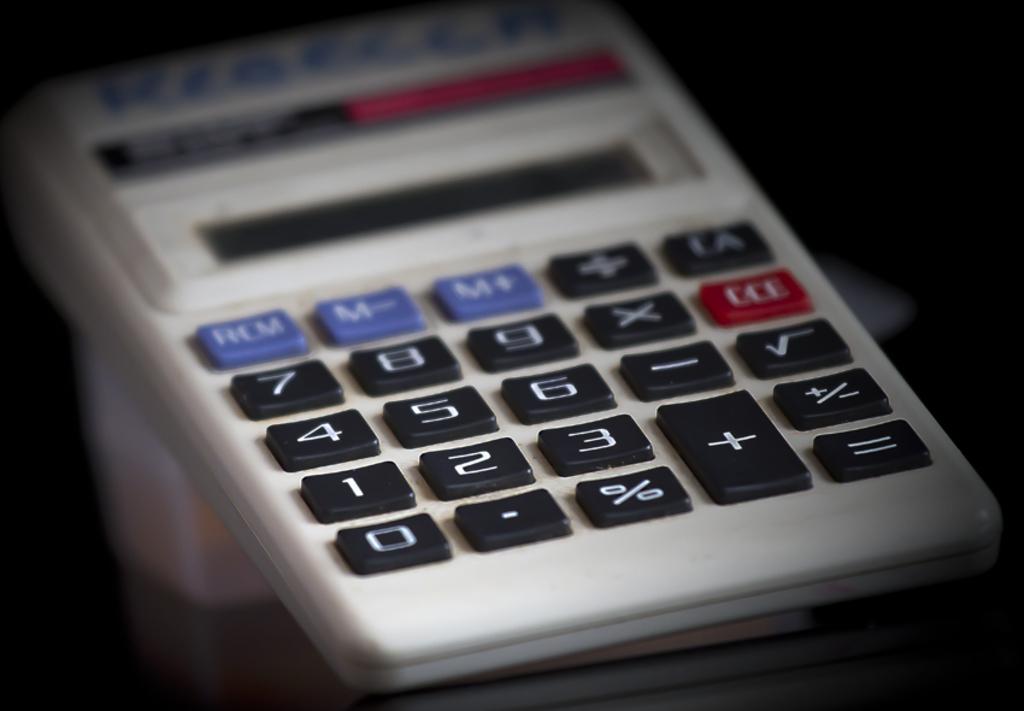Which number is on the lowest left corner?
Ensure brevity in your answer.  0. What is the first blue button?
Provide a succinct answer. Rcm. 